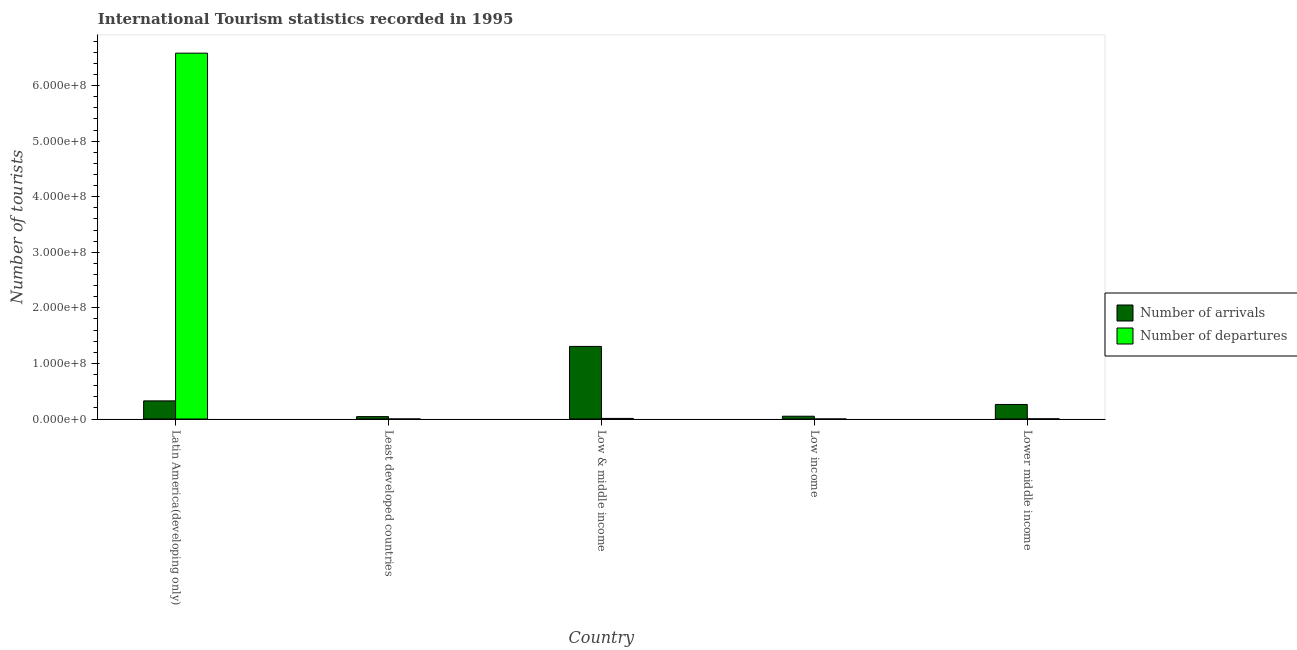How many different coloured bars are there?
Your answer should be very brief. 2. Are the number of bars per tick equal to the number of legend labels?
Offer a terse response. Yes. Are the number of bars on each tick of the X-axis equal?
Provide a succinct answer. Yes. How many bars are there on the 1st tick from the left?
Give a very brief answer. 2. How many bars are there on the 3rd tick from the right?
Provide a succinct answer. 2. What is the label of the 4th group of bars from the left?
Ensure brevity in your answer.  Low income. What is the number of tourist departures in Low & middle income?
Provide a short and direct response. 1.09e+06. Across all countries, what is the maximum number of tourist arrivals?
Give a very brief answer. 1.31e+08. Across all countries, what is the minimum number of tourist arrivals?
Your response must be concise. 4.31e+06. In which country was the number of tourist departures maximum?
Make the answer very short. Latin America(developing only). In which country was the number of tourist arrivals minimum?
Offer a very short reply. Least developed countries. What is the total number of tourist departures in the graph?
Provide a short and direct response. 6.60e+08. What is the difference between the number of tourist arrivals in Latin America(developing only) and that in Low & middle income?
Keep it short and to the point. -9.80e+07. What is the difference between the number of tourist arrivals in Latin America(developing only) and the number of tourist departures in Low & middle income?
Ensure brevity in your answer.  3.15e+07. What is the average number of tourist arrivals per country?
Your answer should be compact. 3.98e+07. What is the difference between the number of tourist departures and number of tourist arrivals in Least developed countries?
Offer a terse response. -4.30e+06. In how many countries, is the number of tourist arrivals greater than 440000000 ?
Your response must be concise. 0. What is the ratio of the number of tourist arrivals in Low income to that in Lower middle income?
Your answer should be compact. 0.19. Is the number of tourist departures in Low income less than that in Lower middle income?
Provide a short and direct response. Yes. Is the difference between the number of tourist arrivals in Latin America(developing only) and Low income greater than the difference between the number of tourist departures in Latin America(developing only) and Low income?
Your answer should be compact. No. What is the difference between the highest and the second highest number of tourist departures?
Ensure brevity in your answer.  6.57e+08. What is the difference between the highest and the lowest number of tourist departures?
Your answer should be very brief. 6.58e+08. What does the 2nd bar from the left in Low income represents?
Your answer should be compact. Number of departures. What does the 2nd bar from the right in Latin America(developing only) represents?
Offer a terse response. Number of arrivals. How many bars are there?
Your answer should be compact. 10. Are all the bars in the graph horizontal?
Provide a succinct answer. No. How many countries are there in the graph?
Provide a succinct answer. 5. Are the values on the major ticks of Y-axis written in scientific E-notation?
Offer a terse response. Yes. Does the graph contain grids?
Make the answer very short. No. Where does the legend appear in the graph?
Keep it short and to the point. Center right. How many legend labels are there?
Make the answer very short. 2. How are the legend labels stacked?
Make the answer very short. Vertical. What is the title of the graph?
Provide a succinct answer. International Tourism statistics recorded in 1995. What is the label or title of the Y-axis?
Your answer should be very brief. Number of tourists. What is the Number of tourists in Number of arrivals in Latin America(developing only)?
Ensure brevity in your answer.  3.26e+07. What is the Number of tourists in Number of departures in Latin America(developing only)?
Your answer should be compact. 6.58e+08. What is the Number of tourists of Number of arrivals in Least developed countries?
Offer a very short reply. 4.31e+06. What is the Number of tourists in Number of departures in Least developed countries?
Keep it short and to the point. 1.20e+04. What is the Number of tourists in Number of arrivals in Low & middle income?
Your answer should be compact. 1.31e+08. What is the Number of tourists of Number of departures in Low & middle income?
Offer a very short reply. 1.09e+06. What is the Number of tourists in Number of arrivals in Low income?
Provide a short and direct response. 5.03e+06. What is the Number of tourists of Number of departures in Low income?
Offer a terse response. 3000. What is the Number of tourists of Number of arrivals in Lower middle income?
Keep it short and to the point. 2.62e+07. What is the Number of tourists of Number of departures in Lower middle income?
Ensure brevity in your answer.  3.86e+05. Across all countries, what is the maximum Number of tourists of Number of arrivals?
Ensure brevity in your answer.  1.31e+08. Across all countries, what is the maximum Number of tourists in Number of departures?
Provide a succinct answer. 6.58e+08. Across all countries, what is the minimum Number of tourists in Number of arrivals?
Ensure brevity in your answer.  4.31e+06. Across all countries, what is the minimum Number of tourists in Number of departures?
Offer a very short reply. 3000. What is the total Number of tourists in Number of arrivals in the graph?
Make the answer very short. 1.99e+08. What is the total Number of tourists in Number of departures in the graph?
Offer a terse response. 6.60e+08. What is the difference between the Number of tourists of Number of arrivals in Latin America(developing only) and that in Least developed countries?
Provide a succinct answer. 2.83e+07. What is the difference between the Number of tourists in Number of departures in Latin America(developing only) and that in Least developed countries?
Your answer should be compact. 6.58e+08. What is the difference between the Number of tourists in Number of arrivals in Latin America(developing only) and that in Low & middle income?
Make the answer very short. -9.80e+07. What is the difference between the Number of tourists in Number of departures in Latin America(developing only) and that in Low & middle income?
Provide a short and direct response. 6.57e+08. What is the difference between the Number of tourists in Number of arrivals in Latin America(developing only) and that in Low income?
Your response must be concise. 2.76e+07. What is the difference between the Number of tourists in Number of departures in Latin America(developing only) and that in Low income?
Give a very brief answer. 6.58e+08. What is the difference between the Number of tourists of Number of arrivals in Latin America(developing only) and that in Lower middle income?
Offer a very short reply. 6.45e+06. What is the difference between the Number of tourists in Number of departures in Latin America(developing only) and that in Lower middle income?
Your answer should be very brief. 6.58e+08. What is the difference between the Number of tourists in Number of arrivals in Least developed countries and that in Low & middle income?
Make the answer very short. -1.26e+08. What is the difference between the Number of tourists in Number of departures in Least developed countries and that in Low & middle income?
Provide a succinct answer. -1.08e+06. What is the difference between the Number of tourists of Number of arrivals in Least developed countries and that in Low income?
Make the answer very short. -7.12e+05. What is the difference between the Number of tourists of Number of departures in Least developed countries and that in Low income?
Your answer should be compact. 9000. What is the difference between the Number of tourists of Number of arrivals in Least developed countries and that in Lower middle income?
Ensure brevity in your answer.  -2.19e+07. What is the difference between the Number of tourists in Number of departures in Least developed countries and that in Lower middle income?
Your response must be concise. -3.74e+05. What is the difference between the Number of tourists in Number of arrivals in Low & middle income and that in Low income?
Keep it short and to the point. 1.26e+08. What is the difference between the Number of tourists in Number of departures in Low & middle income and that in Low income?
Your response must be concise. 1.09e+06. What is the difference between the Number of tourists in Number of arrivals in Low & middle income and that in Lower middle income?
Ensure brevity in your answer.  1.04e+08. What is the difference between the Number of tourists of Number of departures in Low & middle income and that in Lower middle income?
Your response must be concise. 7.04e+05. What is the difference between the Number of tourists of Number of arrivals in Low income and that in Lower middle income?
Keep it short and to the point. -2.12e+07. What is the difference between the Number of tourists of Number of departures in Low income and that in Lower middle income?
Offer a very short reply. -3.83e+05. What is the difference between the Number of tourists in Number of arrivals in Latin America(developing only) and the Number of tourists in Number of departures in Least developed countries?
Your response must be concise. 3.26e+07. What is the difference between the Number of tourists of Number of arrivals in Latin America(developing only) and the Number of tourists of Number of departures in Low & middle income?
Keep it short and to the point. 3.15e+07. What is the difference between the Number of tourists of Number of arrivals in Latin America(developing only) and the Number of tourists of Number of departures in Low income?
Ensure brevity in your answer.  3.26e+07. What is the difference between the Number of tourists in Number of arrivals in Latin America(developing only) and the Number of tourists in Number of departures in Lower middle income?
Ensure brevity in your answer.  3.22e+07. What is the difference between the Number of tourists of Number of arrivals in Least developed countries and the Number of tourists of Number of departures in Low & middle income?
Provide a short and direct response. 3.22e+06. What is the difference between the Number of tourists in Number of arrivals in Least developed countries and the Number of tourists in Number of departures in Low income?
Keep it short and to the point. 4.31e+06. What is the difference between the Number of tourists in Number of arrivals in Least developed countries and the Number of tourists in Number of departures in Lower middle income?
Keep it short and to the point. 3.93e+06. What is the difference between the Number of tourists of Number of arrivals in Low & middle income and the Number of tourists of Number of departures in Low income?
Ensure brevity in your answer.  1.31e+08. What is the difference between the Number of tourists of Number of arrivals in Low & middle income and the Number of tourists of Number of departures in Lower middle income?
Offer a terse response. 1.30e+08. What is the difference between the Number of tourists in Number of arrivals in Low income and the Number of tourists in Number of departures in Lower middle income?
Your answer should be compact. 4.64e+06. What is the average Number of tourists of Number of arrivals per country?
Offer a terse response. 3.98e+07. What is the average Number of tourists of Number of departures per country?
Offer a terse response. 1.32e+08. What is the difference between the Number of tourists in Number of arrivals and Number of tourists in Number of departures in Latin America(developing only)?
Ensure brevity in your answer.  -6.26e+08. What is the difference between the Number of tourists of Number of arrivals and Number of tourists of Number of departures in Least developed countries?
Give a very brief answer. 4.30e+06. What is the difference between the Number of tourists in Number of arrivals and Number of tourists in Number of departures in Low & middle income?
Make the answer very short. 1.30e+08. What is the difference between the Number of tourists in Number of arrivals and Number of tourists in Number of departures in Low income?
Offer a terse response. 5.02e+06. What is the difference between the Number of tourists in Number of arrivals and Number of tourists in Number of departures in Lower middle income?
Provide a succinct answer. 2.58e+07. What is the ratio of the Number of tourists of Number of arrivals in Latin America(developing only) to that in Least developed countries?
Ensure brevity in your answer.  7.56. What is the ratio of the Number of tourists in Number of departures in Latin America(developing only) to that in Least developed countries?
Keep it short and to the point. 5.49e+04. What is the ratio of the Number of tourists of Number of arrivals in Latin America(developing only) to that in Low & middle income?
Make the answer very short. 0.25. What is the ratio of the Number of tourists in Number of departures in Latin America(developing only) to that in Low & middle income?
Ensure brevity in your answer.  603.9. What is the ratio of the Number of tourists in Number of arrivals in Latin America(developing only) to that in Low income?
Your answer should be compact. 6.49. What is the ratio of the Number of tourists in Number of departures in Latin America(developing only) to that in Low income?
Provide a succinct answer. 2.19e+05. What is the ratio of the Number of tourists in Number of arrivals in Latin America(developing only) to that in Lower middle income?
Give a very brief answer. 1.25. What is the ratio of the Number of tourists of Number of departures in Latin America(developing only) to that in Lower middle income?
Make the answer very short. 1705.32. What is the ratio of the Number of tourists of Number of arrivals in Least developed countries to that in Low & middle income?
Give a very brief answer. 0.03. What is the ratio of the Number of tourists in Number of departures in Least developed countries to that in Low & middle income?
Ensure brevity in your answer.  0.01. What is the ratio of the Number of tourists in Number of arrivals in Least developed countries to that in Low income?
Provide a succinct answer. 0.86. What is the ratio of the Number of tourists of Number of arrivals in Least developed countries to that in Lower middle income?
Provide a succinct answer. 0.16. What is the ratio of the Number of tourists in Number of departures in Least developed countries to that in Lower middle income?
Your answer should be very brief. 0.03. What is the ratio of the Number of tourists in Number of arrivals in Low & middle income to that in Low income?
Give a very brief answer. 26. What is the ratio of the Number of tourists of Number of departures in Low & middle income to that in Low income?
Provide a succinct answer. 363.33. What is the ratio of the Number of tourists in Number of arrivals in Low & middle income to that in Lower middle income?
Your answer should be compact. 4.99. What is the ratio of the Number of tourists of Number of departures in Low & middle income to that in Lower middle income?
Make the answer very short. 2.82. What is the ratio of the Number of tourists of Number of arrivals in Low income to that in Lower middle income?
Your answer should be compact. 0.19. What is the ratio of the Number of tourists of Number of departures in Low income to that in Lower middle income?
Provide a succinct answer. 0.01. What is the difference between the highest and the second highest Number of tourists in Number of arrivals?
Offer a very short reply. 9.80e+07. What is the difference between the highest and the second highest Number of tourists in Number of departures?
Your answer should be very brief. 6.57e+08. What is the difference between the highest and the lowest Number of tourists in Number of arrivals?
Keep it short and to the point. 1.26e+08. What is the difference between the highest and the lowest Number of tourists of Number of departures?
Provide a short and direct response. 6.58e+08. 